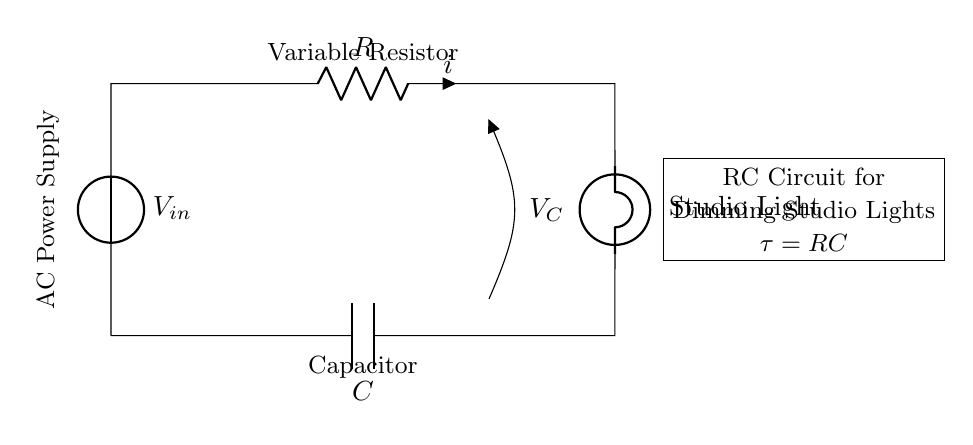What is the component that dims the studio light? The component responsible for dimming the studio light is the variable resistor, which controls the current that flows to the light.
Answer: Variable resistor What are the two main components in this RC circuit? The two main components in this RC circuit are the resistor and the capacitor, which together influence the behavior of the circuit.
Answer: Resistor and capacitor What is the function of the capacitor in this circuit? The capacitor in this circuit stores electrical energy and helps to smooth out the voltage, affecting the brightness of the studio lights over time.
Answer: Store electrical energy What is the significance of the time constant in this circuit? The time constant, denoted as tau, is defined as the product of the resistance and capacitance (tau = RC), which determines how quickly the capacitor charges and discharges, influencing the dimming effect.
Answer: Determines charging and discharging speed What voltage measurement is indicated across the capacitor? The voltage across the capacitor in this circuit is labeled as V_C, which reflects the potential difference at the capacitor while it is charging or discharging.
Answer: V_C How does the variable resistor impact the current in the circuit? The variable resistor adjusts the resistance in the circuit, which in turn alters the current according to Ohm's Law (current equals voltage divided by resistance), thus changing the brightness of the light.
Answer: Alters the current 